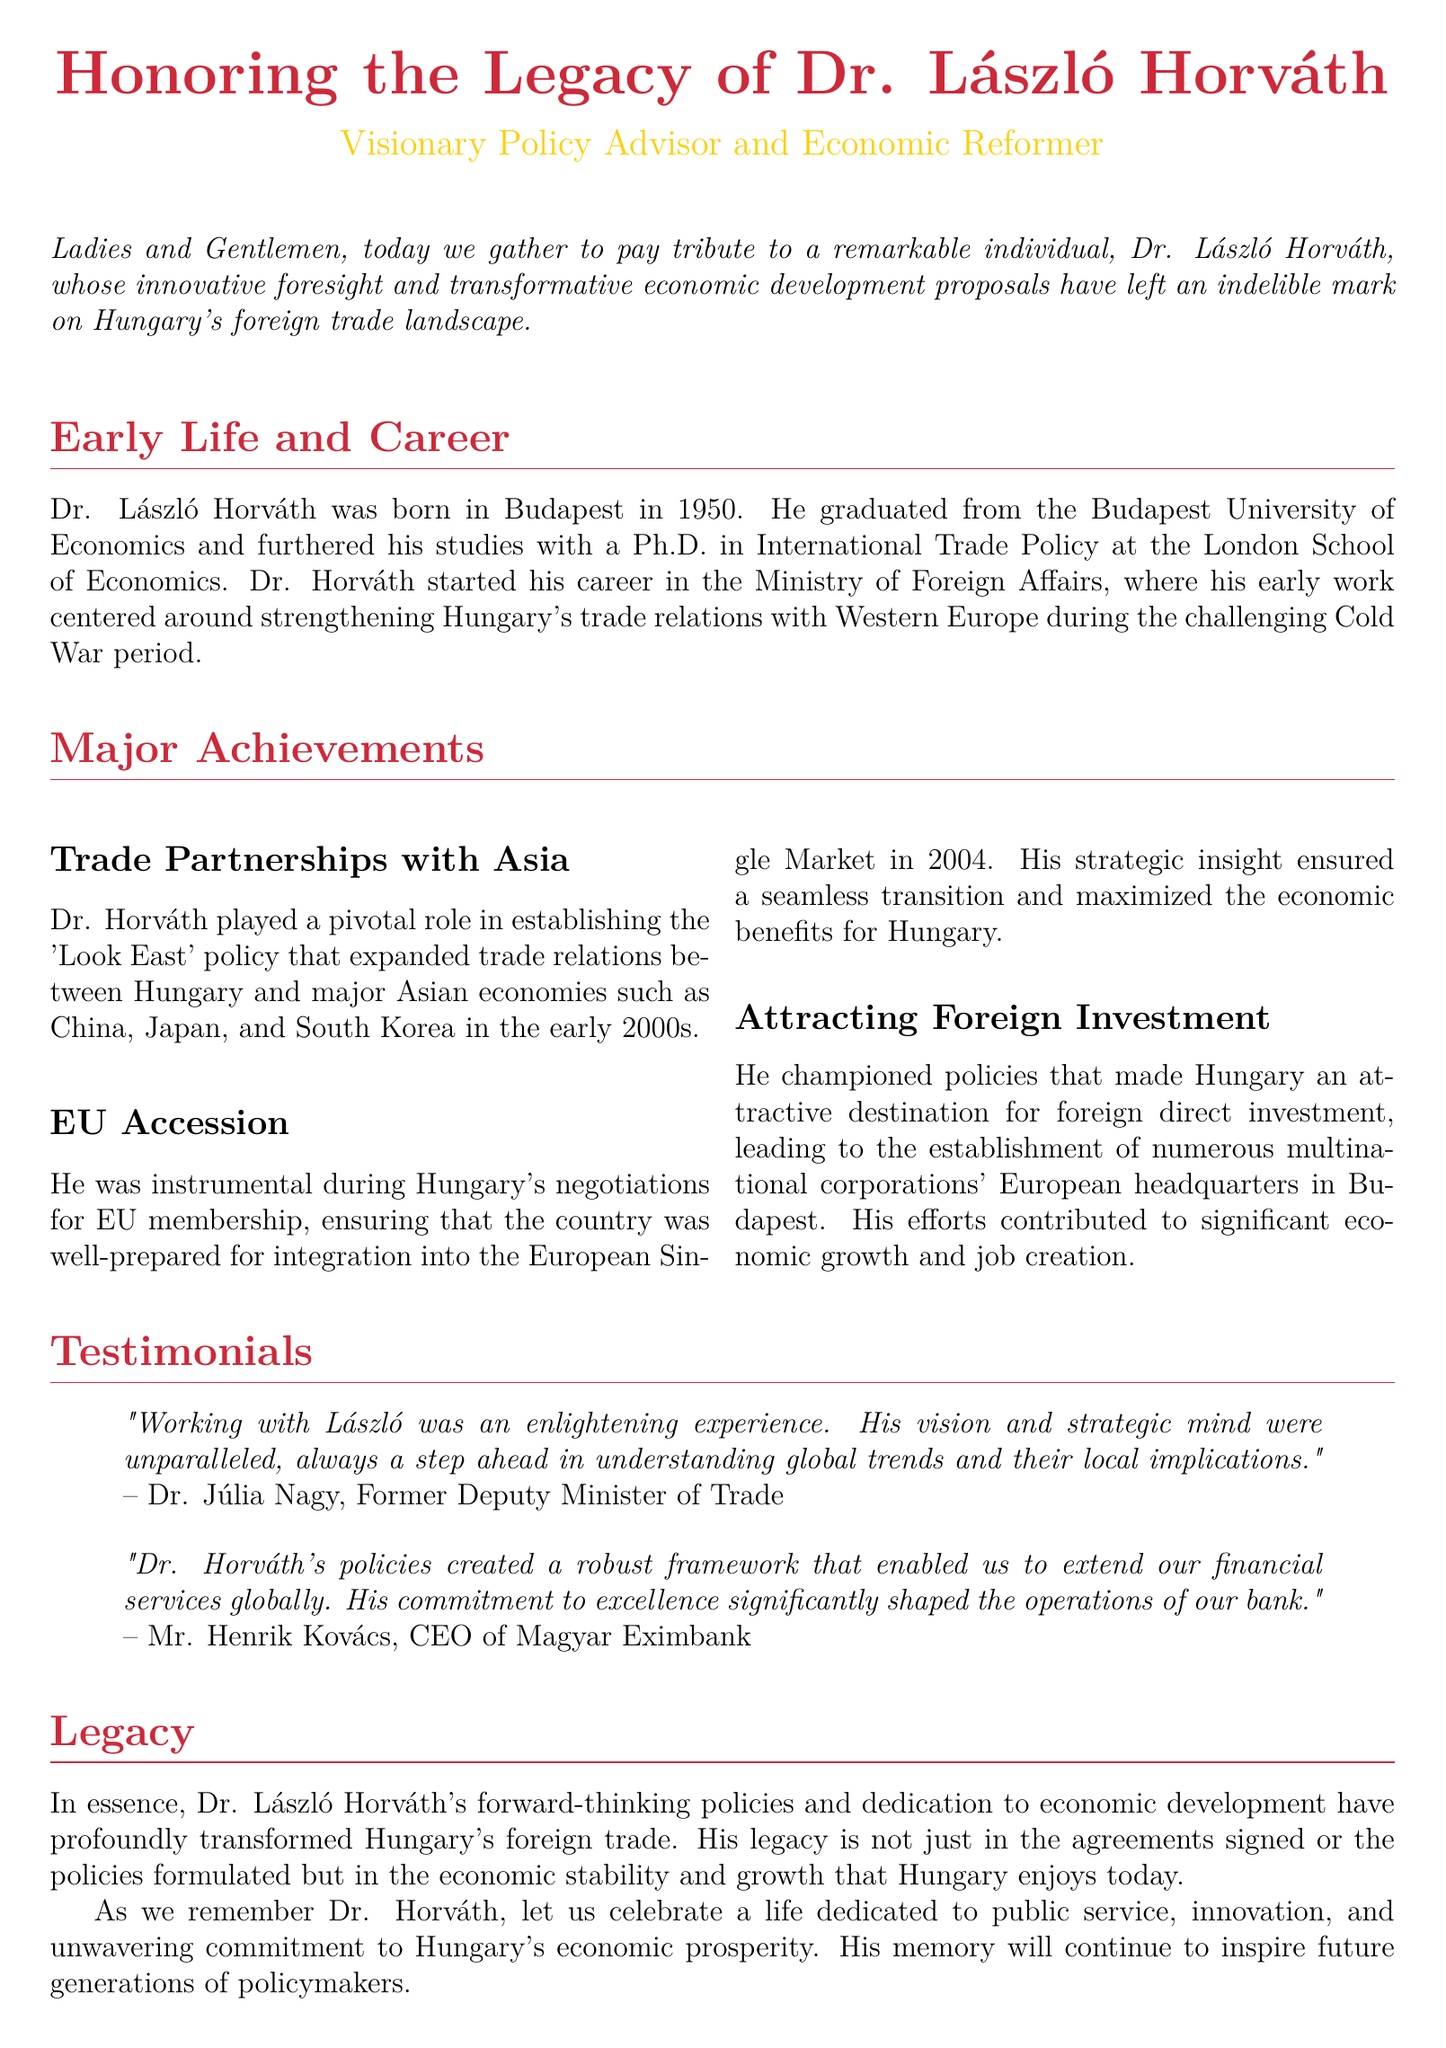What year was Dr. László Horváth born? The document states that Dr. László Horváth was born in Budapest in 1950.
Answer: 1950 What was the name of the policy Dr. Horváth established to enhance trade with Asia? The document refers to this policy as the 'Look East' policy.
Answer: Look East In which year did Hungary join the EU? The document specifies that Hungary integrated into the European Single Market in 2004.
Answer: 2004 Who described Dr. Horváth's strategic mind as unparalleled? The document quotes Dr. Júlia Nagy, former Deputy Minister of Trade.
Answer: Dr. Júlia Nagy What position did Mr. Henrik Kovács hold? The document identifies him as the CEO of Magyar Eximbank.
Answer: CEO of Magyar Eximbank What was one of the main outcomes of Dr. Horváth's efforts regarding foreign investment? The document mentions the establishment of numerous multinational corporations' European headquarters in Budapest.
Answer: European headquarters Which university did Dr. Horváth graduate from? The document states he graduated from the Budapest University of Economics.
Answer: Budapest University of Economics What aspect of Hungary's economy did Dr. Horváth significantly transform? The document notes that he transformed Hungary's foreign trade landscape.
Answer: Foreign trade landscape 